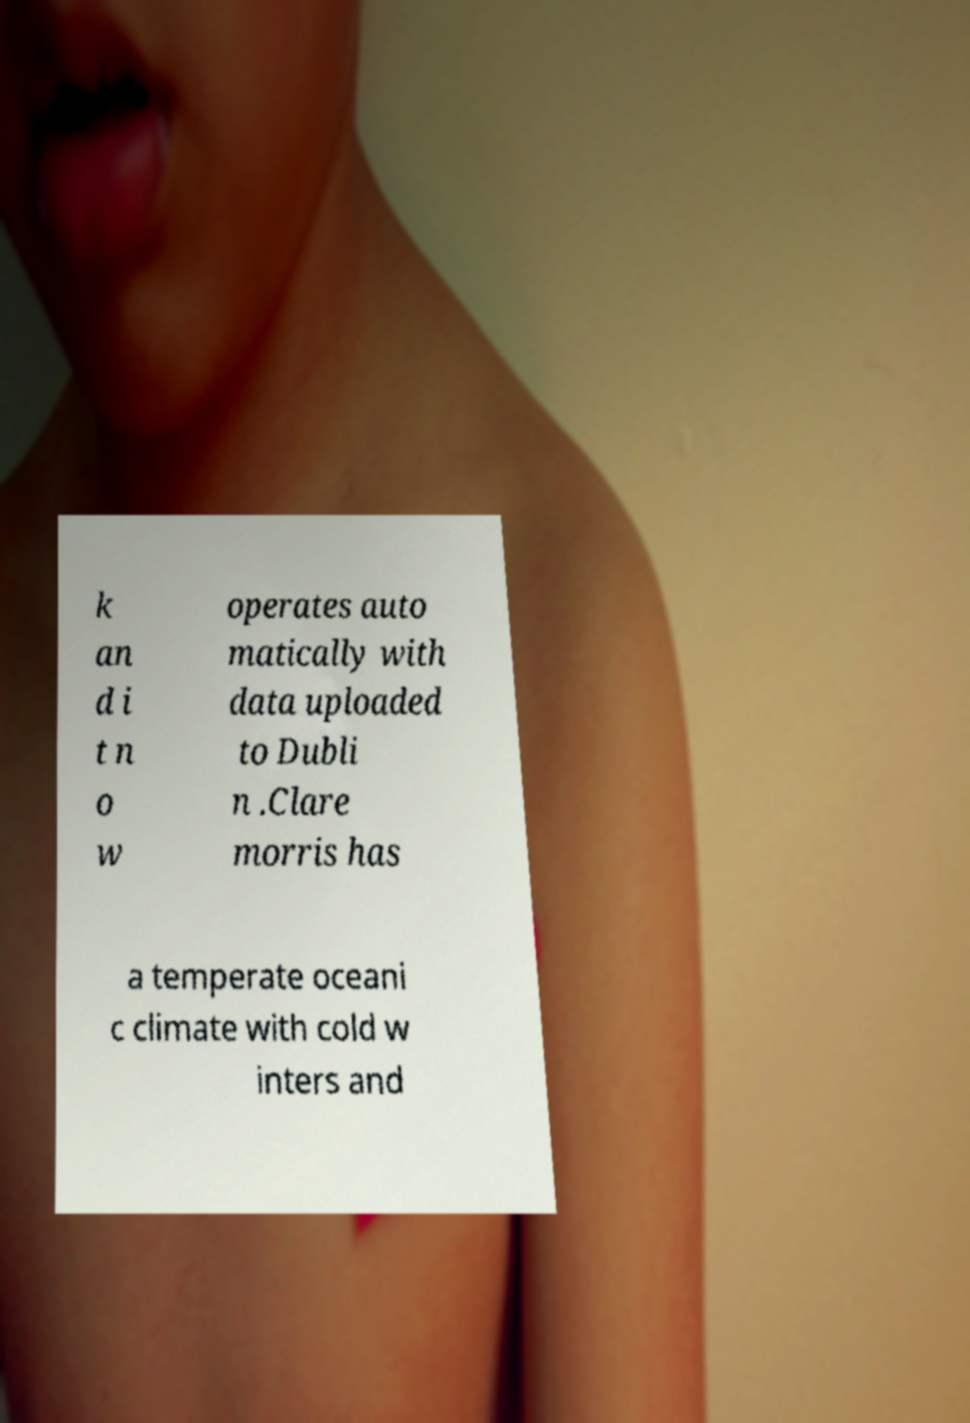Please read and relay the text visible in this image. What does it say? k an d i t n o w operates auto matically with data uploaded to Dubli n .Clare morris has a temperate oceani c climate with cold w inters and 